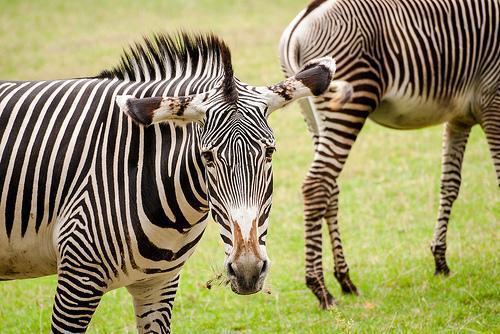How many animals are there?
Give a very brief answer. 2. 